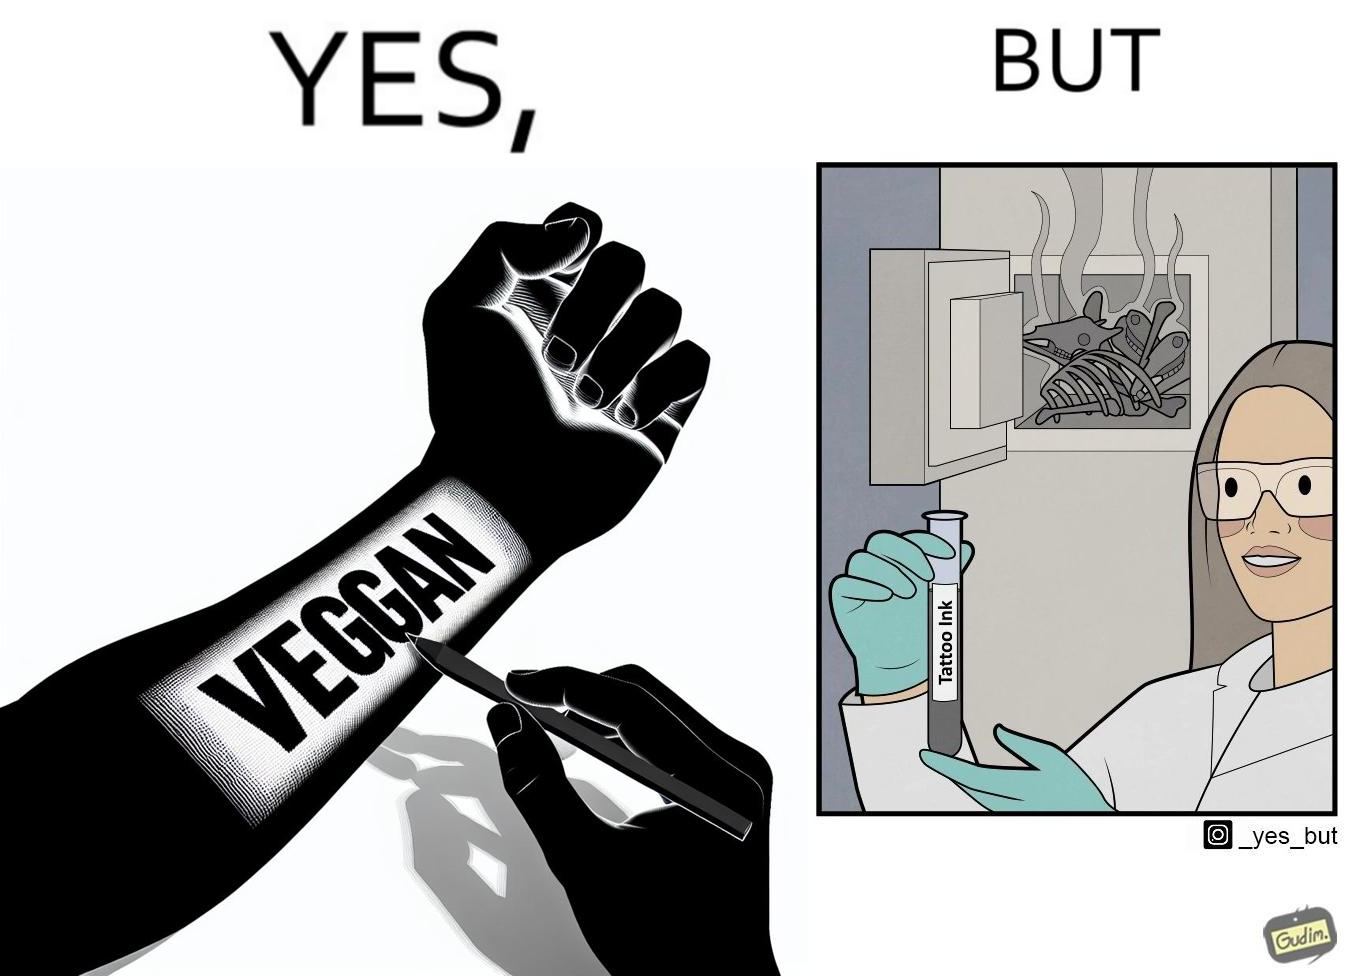What is the satirical meaning behind this image? The irony in this video is that people try to promote and embrace veganism end up using products that are not animal-free. 